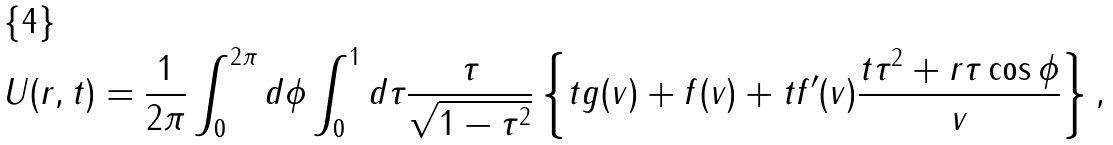<formula> <loc_0><loc_0><loc_500><loc_500>U ( r , t ) = \frac { 1 } { 2 \pi } \int _ { 0 } ^ { 2 \pi } d \phi \int _ { 0 } ^ { 1 } d \tau \frac { \tau } { \sqrt { 1 - \tau ^ { 2 } } } \left \{ t g ( v ) + f ( v ) + t f ^ { \prime } ( v ) \frac { t \tau ^ { 2 } + r \tau \cos \phi } { v } \right \} ,</formula> 